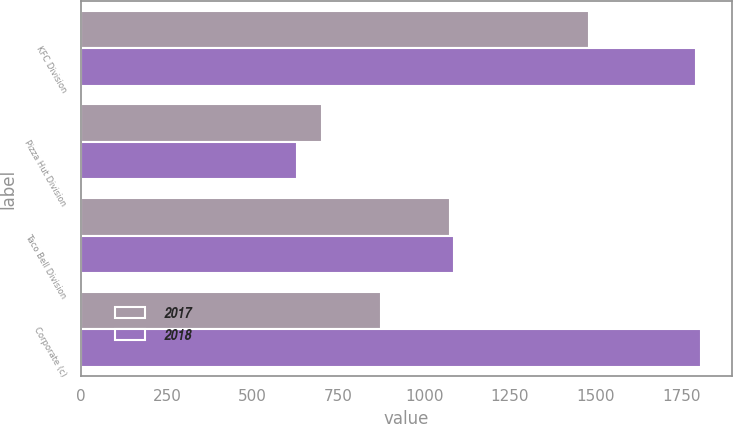Convert chart to OTSL. <chart><loc_0><loc_0><loc_500><loc_500><stacked_bar_chart><ecel><fcel>KFC Division<fcel>Pizza Hut Division<fcel>Taco Bell Division<fcel>Corporate (c)<nl><fcel>2017<fcel>1481<fcel>701<fcel>1074<fcel>874<nl><fcel>2018<fcel>1791<fcel>628<fcel>1086<fcel>1806<nl></chart> 